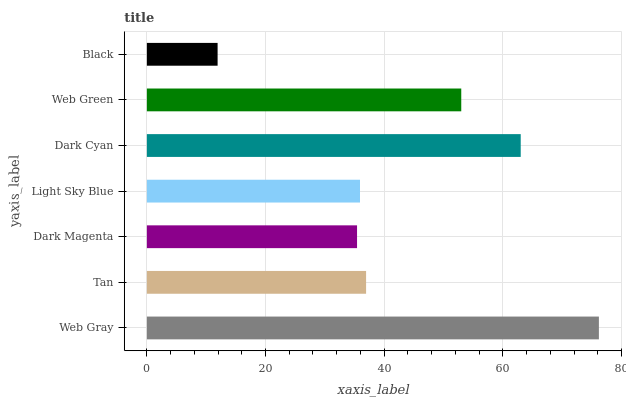Is Black the minimum?
Answer yes or no. Yes. Is Web Gray the maximum?
Answer yes or no. Yes. Is Tan the minimum?
Answer yes or no. No. Is Tan the maximum?
Answer yes or no. No. Is Web Gray greater than Tan?
Answer yes or no. Yes. Is Tan less than Web Gray?
Answer yes or no. Yes. Is Tan greater than Web Gray?
Answer yes or no. No. Is Web Gray less than Tan?
Answer yes or no. No. Is Tan the high median?
Answer yes or no. Yes. Is Tan the low median?
Answer yes or no. Yes. Is Web Gray the high median?
Answer yes or no. No. Is Web Gray the low median?
Answer yes or no. No. 